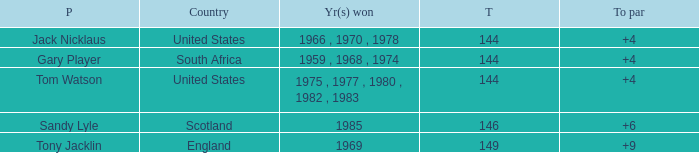What player had a To par smaller than 9 and won in 1985? Sandy Lyle. 